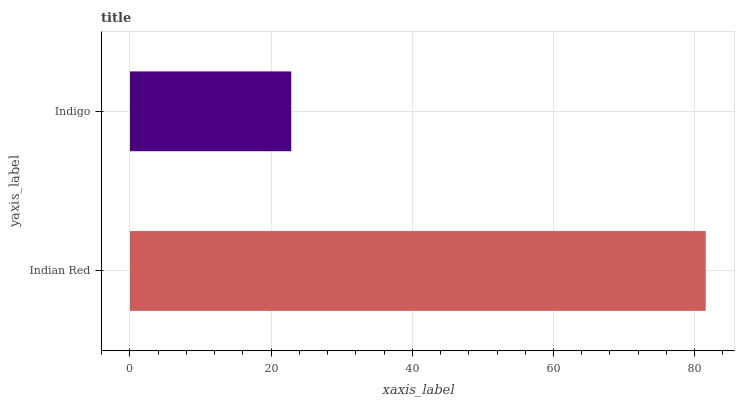Is Indigo the minimum?
Answer yes or no. Yes. Is Indian Red the maximum?
Answer yes or no. Yes. Is Indigo the maximum?
Answer yes or no. No. Is Indian Red greater than Indigo?
Answer yes or no. Yes. Is Indigo less than Indian Red?
Answer yes or no. Yes. Is Indigo greater than Indian Red?
Answer yes or no. No. Is Indian Red less than Indigo?
Answer yes or no. No. Is Indian Red the high median?
Answer yes or no. Yes. Is Indigo the low median?
Answer yes or no. Yes. Is Indigo the high median?
Answer yes or no. No. Is Indian Red the low median?
Answer yes or no. No. 